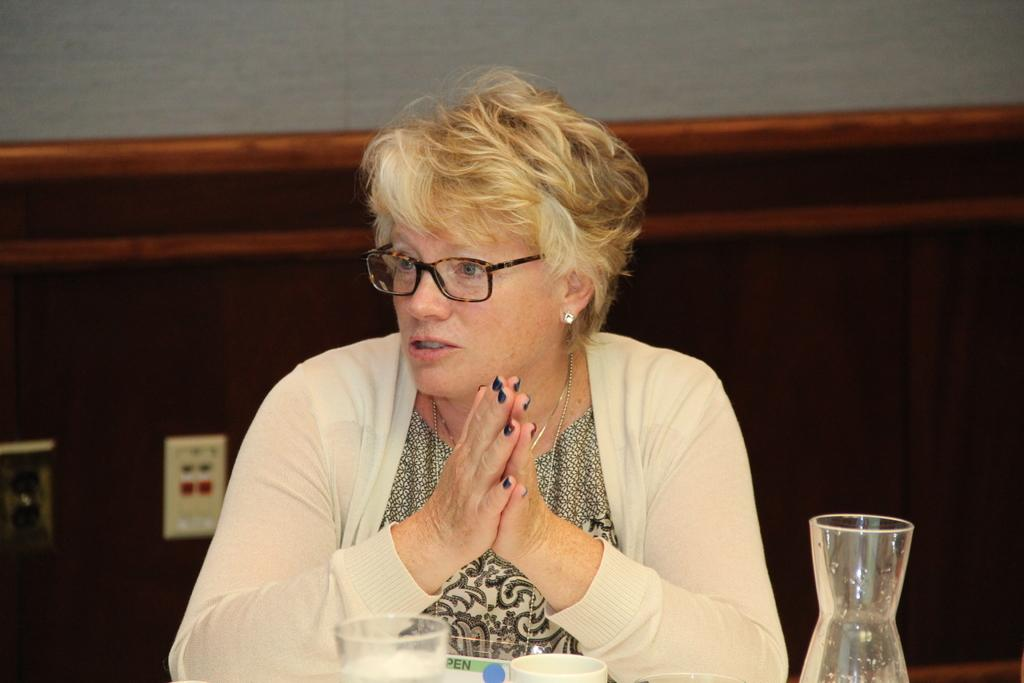Who is present in the image? There is a woman in the image. What is the woman doing in the image? The woman is sitting and speaking. What objects are in front of the woman? There is a glass and a cup in front of the woman. What can be seen behind the woman? There is a wooden wall behind the woman. How many rabbits are hopping on the stage in the image? There are no rabbits or stage present in the image. 